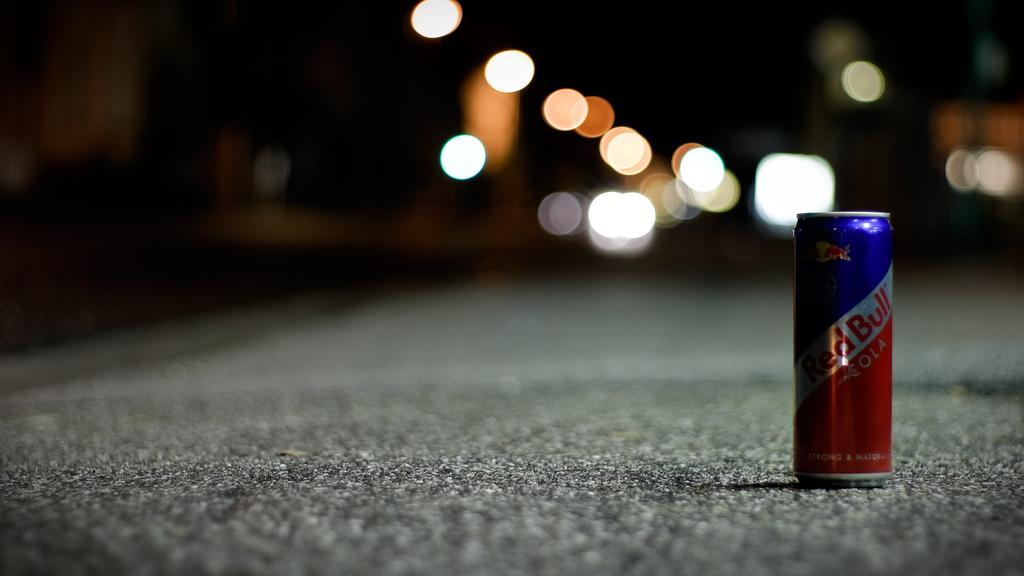Provide a one-sentence caption for the provided image. A lone can of Red Bull sits on a paved road. 